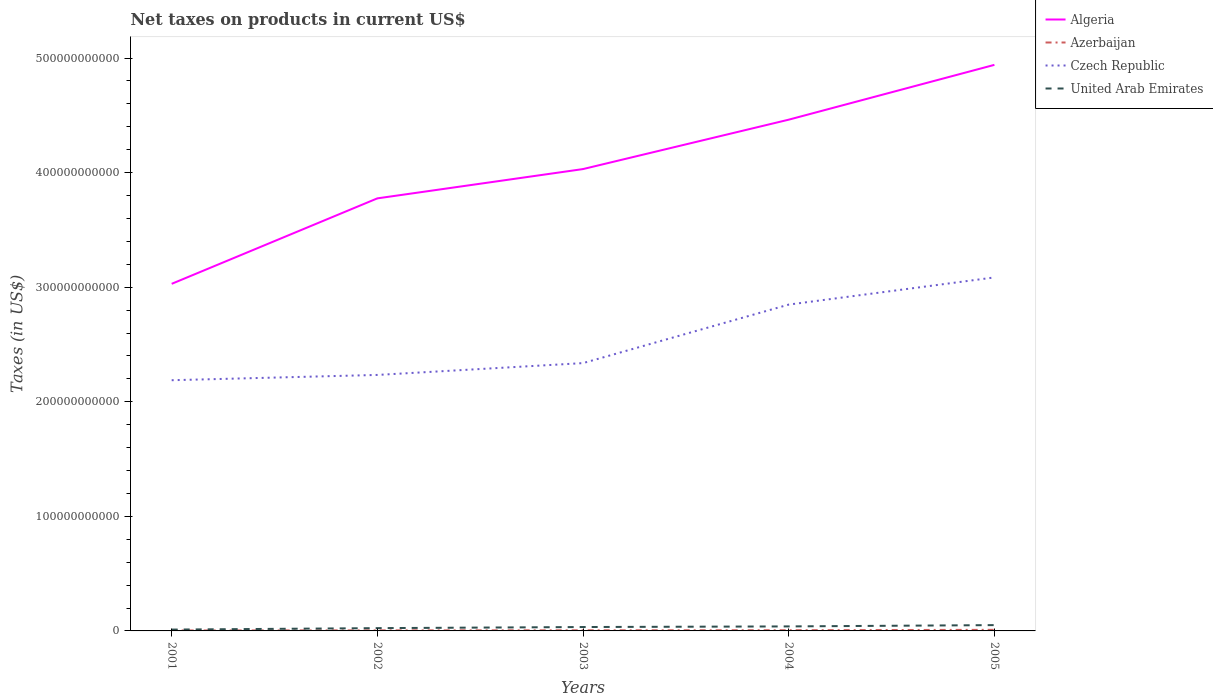Does the line corresponding to Czech Republic intersect with the line corresponding to United Arab Emirates?
Your answer should be very brief. No. Is the number of lines equal to the number of legend labels?
Ensure brevity in your answer.  Yes. Across all years, what is the maximum net taxes on products in Czech Republic?
Keep it short and to the point. 2.19e+11. In which year was the net taxes on products in Czech Republic maximum?
Provide a succinct answer. 2001. What is the total net taxes on products in Czech Republic in the graph?
Keep it short and to the point. -7.48e+1. What is the difference between the highest and the second highest net taxes on products in Algeria?
Keep it short and to the point. 1.91e+11. What is the difference between the highest and the lowest net taxes on products in Czech Republic?
Provide a short and direct response. 2. Is the net taxes on products in Algeria strictly greater than the net taxes on products in Czech Republic over the years?
Your answer should be compact. No. What is the difference between two consecutive major ticks on the Y-axis?
Make the answer very short. 1.00e+11. Does the graph contain grids?
Your answer should be very brief. No. What is the title of the graph?
Offer a very short reply. Net taxes on products in current US$. What is the label or title of the Y-axis?
Provide a succinct answer. Taxes (in US$). What is the Taxes (in US$) in Algeria in 2001?
Keep it short and to the point. 3.03e+11. What is the Taxes (in US$) of Azerbaijan in 2001?
Ensure brevity in your answer.  4.18e+08. What is the Taxes (in US$) of Czech Republic in 2001?
Your answer should be compact. 2.19e+11. What is the Taxes (in US$) in United Arab Emirates in 2001?
Make the answer very short. 1.17e+09. What is the Taxes (in US$) in Algeria in 2002?
Provide a short and direct response. 3.78e+11. What is the Taxes (in US$) of Azerbaijan in 2002?
Give a very brief answer. 4.86e+08. What is the Taxes (in US$) of Czech Republic in 2002?
Your answer should be very brief. 2.23e+11. What is the Taxes (in US$) of United Arab Emirates in 2002?
Provide a succinct answer. 2.43e+09. What is the Taxes (in US$) of Algeria in 2003?
Offer a very short reply. 4.03e+11. What is the Taxes (in US$) of Azerbaijan in 2003?
Your response must be concise. 5.50e+08. What is the Taxes (in US$) in Czech Republic in 2003?
Your answer should be very brief. 2.34e+11. What is the Taxes (in US$) of United Arab Emirates in 2003?
Your answer should be compact. 3.40e+09. What is the Taxes (in US$) of Algeria in 2004?
Your answer should be very brief. 4.46e+11. What is the Taxes (in US$) in Azerbaijan in 2004?
Ensure brevity in your answer.  6.16e+08. What is the Taxes (in US$) in Czech Republic in 2004?
Ensure brevity in your answer.  2.85e+11. What is the Taxes (in US$) in United Arab Emirates in 2004?
Offer a terse response. 3.94e+09. What is the Taxes (in US$) in Algeria in 2005?
Ensure brevity in your answer.  4.94e+11. What is the Taxes (in US$) of Azerbaijan in 2005?
Provide a succinct answer. 9.46e+08. What is the Taxes (in US$) in Czech Republic in 2005?
Offer a very short reply. 3.09e+11. What is the Taxes (in US$) of United Arab Emirates in 2005?
Provide a short and direct response. 5.07e+09. Across all years, what is the maximum Taxes (in US$) in Algeria?
Offer a very short reply. 4.94e+11. Across all years, what is the maximum Taxes (in US$) in Azerbaijan?
Give a very brief answer. 9.46e+08. Across all years, what is the maximum Taxes (in US$) in Czech Republic?
Offer a terse response. 3.09e+11. Across all years, what is the maximum Taxes (in US$) of United Arab Emirates?
Keep it short and to the point. 5.07e+09. Across all years, what is the minimum Taxes (in US$) of Algeria?
Your response must be concise. 3.03e+11. Across all years, what is the minimum Taxes (in US$) in Azerbaijan?
Make the answer very short. 4.18e+08. Across all years, what is the minimum Taxes (in US$) of Czech Republic?
Make the answer very short. 2.19e+11. Across all years, what is the minimum Taxes (in US$) in United Arab Emirates?
Provide a succinct answer. 1.17e+09. What is the total Taxes (in US$) of Algeria in the graph?
Make the answer very short. 2.02e+12. What is the total Taxes (in US$) of Azerbaijan in the graph?
Ensure brevity in your answer.  3.02e+09. What is the total Taxes (in US$) of Czech Republic in the graph?
Offer a terse response. 1.27e+12. What is the total Taxes (in US$) of United Arab Emirates in the graph?
Your response must be concise. 1.60e+1. What is the difference between the Taxes (in US$) in Algeria in 2001 and that in 2002?
Offer a very short reply. -7.46e+1. What is the difference between the Taxes (in US$) in Azerbaijan in 2001 and that in 2002?
Your answer should be very brief. -6.79e+07. What is the difference between the Taxes (in US$) in Czech Republic in 2001 and that in 2002?
Offer a very short reply. -4.61e+09. What is the difference between the Taxes (in US$) of United Arab Emirates in 2001 and that in 2002?
Provide a succinct answer. -1.26e+09. What is the difference between the Taxes (in US$) in Algeria in 2001 and that in 2003?
Keep it short and to the point. -1.00e+11. What is the difference between the Taxes (in US$) in Azerbaijan in 2001 and that in 2003?
Your response must be concise. -1.31e+08. What is the difference between the Taxes (in US$) of Czech Republic in 2001 and that in 2003?
Give a very brief answer. -1.49e+1. What is the difference between the Taxes (in US$) in United Arab Emirates in 2001 and that in 2003?
Your answer should be very brief. -2.23e+09. What is the difference between the Taxes (in US$) of Algeria in 2001 and that in 2004?
Provide a short and direct response. -1.43e+11. What is the difference between the Taxes (in US$) in Azerbaijan in 2001 and that in 2004?
Make the answer very short. -1.97e+08. What is the difference between the Taxes (in US$) of Czech Republic in 2001 and that in 2004?
Offer a terse response. -6.60e+1. What is the difference between the Taxes (in US$) in United Arab Emirates in 2001 and that in 2004?
Give a very brief answer. -2.77e+09. What is the difference between the Taxes (in US$) of Algeria in 2001 and that in 2005?
Make the answer very short. -1.91e+11. What is the difference between the Taxes (in US$) in Azerbaijan in 2001 and that in 2005?
Offer a terse response. -5.28e+08. What is the difference between the Taxes (in US$) in Czech Republic in 2001 and that in 2005?
Offer a terse response. -8.97e+1. What is the difference between the Taxes (in US$) in United Arab Emirates in 2001 and that in 2005?
Ensure brevity in your answer.  -3.90e+09. What is the difference between the Taxes (in US$) in Algeria in 2002 and that in 2003?
Offer a terse response. -2.56e+1. What is the difference between the Taxes (in US$) in Azerbaijan in 2002 and that in 2003?
Your response must be concise. -6.35e+07. What is the difference between the Taxes (in US$) of Czech Republic in 2002 and that in 2003?
Offer a very short reply. -1.03e+1. What is the difference between the Taxes (in US$) of United Arab Emirates in 2002 and that in 2003?
Your response must be concise. -9.66e+08. What is the difference between the Taxes (in US$) in Algeria in 2002 and that in 2004?
Keep it short and to the point. -6.87e+1. What is the difference between the Taxes (in US$) in Azerbaijan in 2002 and that in 2004?
Offer a terse response. -1.29e+08. What is the difference between the Taxes (in US$) of Czech Republic in 2002 and that in 2004?
Provide a short and direct response. -6.14e+1. What is the difference between the Taxes (in US$) in United Arab Emirates in 2002 and that in 2004?
Ensure brevity in your answer.  -1.50e+09. What is the difference between the Taxes (in US$) of Algeria in 2002 and that in 2005?
Your answer should be compact. -1.17e+11. What is the difference between the Taxes (in US$) in Azerbaijan in 2002 and that in 2005?
Offer a very short reply. -4.60e+08. What is the difference between the Taxes (in US$) of Czech Republic in 2002 and that in 2005?
Provide a succinct answer. -8.51e+1. What is the difference between the Taxes (in US$) in United Arab Emirates in 2002 and that in 2005?
Ensure brevity in your answer.  -2.64e+09. What is the difference between the Taxes (in US$) of Algeria in 2003 and that in 2004?
Provide a succinct answer. -4.31e+1. What is the difference between the Taxes (in US$) in Azerbaijan in 2003 and that in 2004?
Ensure brevity in your answer.  -6.60e+07. What is the difference between the Taxes (in US$) in Czech Republic in 2003 and that in 2004?
Keep it short and to the point. -5.11e+1. What is the difference between the Taxes (in US$) in United Arab Emirates in 2003 and that in 2004?
Your response must be concise. -5.39e+08. What is the difference between the Taxes (in US$) in Algeria in 2003 and that in 2005?
Your answer should be very brief. -9.09e+1. What is the difference between the Taxes (in US$) of Azerbaijan in 2003 and that in 2005?
Your answer should be compact. -3.97e+08. What is the difference between the Taxes (in US$) of Czech Republic in 2003 and that in 2005?
Keep it short and to the point. -7.48e+1. What is the difference between the Taxes (in US$) of United Arab Emirates in 2003 and that in 2005?
Ensure brevity in your answer.  -1.67e+09. What is the difference between the Taxes (in US$) in Algeria in 2004 and that in 2005?
Offer a terse response. -4.78e+1. What is the difference between the Taxes (in US$) in Azerbaijan in 2004 and that in 2005?
Your answer should be very brief. -3.31e+08. What is the difference between the Taxes (in US$) in Czech Republic in 2004 and that in 2005?
Provide a succinct answer. -2.37e+1. What is the difference between the Taxes (in US$) of United Arab Emirates in 2004 and that in 2005?
Your answer should be compact. -1.14e+09. What is the difference between the Taxes (in US$) in Algeria in 2001 and the Taxes (in US$) in Azerbaijan in 2002?
Ensure brevity in your answer.  3.02e+11. What is the difference between the Taxes (in US$) in Algeria in 2001 and the Taxes (in US$) in Czech Republic in 2002?
Keep it short and to the point. 7.95e+1. What is the difference between the Taxes (in US$) in Algeria in 2001 and the Taxes (in US$) in United Arab Emirates in 2002?
Offer a very short reply. 3.00e+11. What is the difference between the Taxes (in US$) of Azerbaijan in 2001 and the Taxes (in US$) of Czech Republic in 2002?
Provide a short and direct response. -2.23e+11. What is the difference between the Taxes (in US$) in Azerbaijan in 2001 and the Taxes (in US$) in United Arab Emirates in 2002?
Your answer should be very brief. -2.01e+09. What is the difference between the Taxes (in US$) in Czech Republic in 2001 and the Taxes (in US$) in United Arab Emirates in 2002?
Your answer should be very brief. 2.16e+11. What is the difference between the Taxes (in US$) of Algeria in 2001 and the Taxes (in US$) of Azerbaijan in 2003?
Offer a terse response. 3.02e+11. What is the difference between the Taxes (in US$) in Algeria in 2001 and the Taxes (in US$) in Czech Republic in 2003?
Your answer should be compact. 6.92e+1. What is the difference between the Taxes (in US$) in Algeria in 2001 and the Taxes (in US$) in United Arab Emirates in 2003?
Your answer should be very brief. 3.00e+11. What is the difference between the Taxes (in US$) in Azerbaijan in 2001 and the Taxes (in US$) in Czech Republic in 2003?
Keep it short and to the point. -2.33e+11. What is the difference between the Taxes (in US$) in Azerbaijan in 2001 and the Taxes (in US$) in United Arab Emirates in 2003?
Keep it short and to the point. -2.98e+09. What is the difference between the Taxes (in US$) in Czech Republic in 2001 and the Taxes (in US$) in United Arab Emirates in 2003?
Ensure brevity in your answer.  2.15e+11. What is the difference between the Taxes (in US$) of Algeria in 2001 and the Taxes (in US$) of Azerbaijan in 2004?
Offer a very short reply. 3.02e+11. What is the difference between the Taxes (in US$) in Algeria in 2001 and the Taxes (in US$) in Czech Republic in 2004?
Ensure brevity in your answer.  1.81e+1. What is the difference between the Taxes (in US$) in Algeria in 2001 and the Taxes (in US$) in United Arab Emirates in 2004?
Your answer should be very brief. 2.99e+11. What is the difference between the Taxes (in US$) of Azerbaijan in 2001 and the Taxes (in US$) of Czech Republic in 2004?
Provide a succinct answer. -2.84e+11. What is the difference between the Taxes (in US$) of Azerbaijan in 2001 and the Taxes (in US$) of United Arab Emirates in 2004?
Your answer should be very brief. -3.52e+09. What is the difference between the Taxes (in US$) of Czech Republic in 2001 and the Taxes (in US$) of United Arab Emirates in 2004?
Make the answer very short. 2.15e+11. What is the difference between the Taxes (in US$) in Algeria in 2001 and the Taxes (in US$) in Azerbaijan in 2005?
Provide a short and direct response. 3.02e+11. What is the difference between the Taxes (in US$) in Algeria in 2001 and the Taxes (in US$) in Czech Republic in 2005?
Offer a very short reply. -5.60e+09. What is the difference between the Taxes (in US$) in Algeria in 2001 and the Taxes (in US$) in United Arab Emirates in 2005?
Make the answer very short. 2.98e+11. What is the difference between the Taxes (in US$) in Azerbaijan in 2001 and the Taxes (in US$) in Czech Republic in 2005?
Your answer should be compact. -3.08e+11. What is the difference between the Taxes (in US$) in Azerbaijan in 2001 and the Taxes (in US$) in United Arab Emirates in 2005?
Your answer should be compact. -4.65e+09. What is the difference between the Taxes (in US$) of Czech Republic in 2001 and the Taxes (in US$) of United Arab Emirates in 2005?
Provide a succinct answer. 2.14e+11. What is the difference between the Taxes (in US$) of Algeria in 2002 and the Taxes (in US$) of Azerbaijan in 2003?
Offer a terse response. 3.77e+11. What is the difference between the Taxes (in US$) of Algeria in 2002 and the Taxes (in US$) of Czech Republic in 2003?
Your answer should be very brief. 1.44e+11. What is the difference between the Taxes (in US$) in Algeria in 2002 and the Taxes (in US$) in United Arab Emirates in 2003?
Your answer should be very brief. 3.74e+11. What is the difference between the Taxes (in US$) in Azerbaijan in 2002 and the Taxes (in US$) in Czech Republic in 2003?
Offer a very short reply. -2.33e+11. What is the difference between the Taxes (in US$) in Azerbaijan in 2002 and the Taxes (in US$) in United Arab Emirates in 2003?
Offer a very short reply. -2.91e+09. What is the difference between the Taxes (in US$) in Czech Republic in 2002 and the Taxes (in US$) in United Arab Emirates in 2003?
Make the answer very short. 2.20e+11. What is the difference between the Taxes (in US$) of Algeria in 2002 and the Taxes (in US$) of Azerbaijan in 2004?
Offer a very short reply. 3.77e+11. What is the difference between the Taxes (in US$) of Algeria in 2002 and the Taxes (in US$) of Czech Republic in 2004?
Your answer should be very brief. 9.27e+1. What is the difference between the Taxes (in US$) of Algeria in 2002 and the Taxes (in US$) of United Arab Emirates in 2004?
Your answer should be very brief. 3.74e+11. What is the difference between the Taxes (in US$) of Azerbaijan in 2002 and the Taxes (in US$) of Czech Republic in 2004?
Offer a very short reply. -2.84e+11. What is the difference between the Taxes (in US$) of Azerbaijan in 2002 and the Taxes (in US$) of United Arab Emirates in 2004?
Keep it short and to the point. -3.45e+09. What is the difference between the Taxes (in US$) of Czech Republic in 2002 and the Taxes (in US$) of United Arab Emirates in 2004?
Your answer should be very brief. 2.19e+11. What is the difference between the Taxes (in US$) in Algeria in 2002 and the Taxes (in US$) in Azerbaijan in 2005?
Your answer should be compact. 3.77e+11. What is the difference between the Taxes (in US$) of Algeria in 2002 and the Taxes (in US$) of Czech Republic in 2005?
Your answer should be very brief. 6.90e+1. What is the difference between the Taxes (in US$) of Algeria in 2002 and the Taxes (in US$) of United Arab Emirates in 2005?
Provide a succinct answer. 3.72e+11. What is the difference between the Taxes (in US$) in Azerbaijan in 2002 and the Taxes (in US$) in Czech Republic in 2005?
Offer a very short reply. -3.08e+11. What is the difference between the Taxes (in US$) in Azerbaijan in 2002 and the Taxes (in US$) in United Arab Emirates in 2005?
Provide a short and direct response. -4.58e+09. What is the difference between the Taxes (in US$) of Czech Republic in 2002 and the Taxes (in US$) of United Arab Emirates in 2005?
Your response must be concise. 2.18e+11. What is the difference between the Taxes (in US$) in Algeria in 2003 and the Taxes (in US$) in Azerbaijan in 2004?
Give a very brief answer. 4.02e+11. What is the difference between the Taxes (in US$) of Algeria in 2003 and the Taxes (in US$) of Czech Republic in 2004?
Provide a succinct answer. 1.18e+11. What is the difference between the Taxes (in US$) in Algeria in 2003 and the Taxes (in US$) in United Arab Emirates in 2004?
Make the answer very short. 3.99e+11. What is the difference between the Taxes (in US$) of Azerbaijan in 2003 and the Taxes (in US$) of Czech Republic in 2004?
Give a very brief answer. -2.84e+11. What is the difference between the Taxes (in US$) in Azerbaijan in 2003 and the Taxes (in US$) in United Arab Emirates in 2004?
Make the answer very short. -3.39e+09. What is the difference between the Taxes (in US$) of Czech Republic in 2003 and the Taxes (in US$) of United Arab Emirates in 2004?
Ensure brevity in your answer.  2.30e+11. What is the difference between the Taxes (in US$) of Algeria in 2003 and the Taxes (in US$) of Azerbaijan in 2005?
Provide a short and direct response. 4.02e+11. What is the difference between the Taxes (in US$) of Algeria in 2003 and the Taxes (in US$) of Czech Republic in 2005?
Your answer should be compact. 9.46e+1. What is the difference between the Taxes (in US$) of Algeria in 2003 and the Taxes (in US$) of United Arab Emirates in 2005?
Provide a succinct answer. 3.98e+11. What is the difference between the Taxes (in US$) in Azerbaijan in 2003 and the Taxes (in US$) in Czech Republic in 2005?
Your answer should be very brief. -3.08e+11. What is the difference between the Taxes (in US$) in Azerbaijan in 2003 and the Taxes (in US$) in United Arab Emirates in 2005?
Provide a succinct answer. -4.52e+09. What is the difference between the Taxes (in US$) in Czech Republic in 2003 and the Taxes (in US$) in United Arab Emirates in 2005?
Make the answer very short. 2.29e+11. What is the difference between the Taxes (in US$) of Algeria in 2004 and the Taxes (in US$) of Azerbaijan in 2005?
Keep it short and to the point. 4.45e+11. What is the difference between the Taxes (in US$) in Algeria in 2004 and the Taxes (in US$) in Czech Republic in 2005?
Offer a terse response. 1.38e+11. What is the difference between the Taxes (in US$) in Algeria in 2004 and the Taxes (in US$) in United Arab Emirates in 2005?
Give a very brief answer. 4.41e+11. What is the difference between the Taxes (in US$) of Azerbaijan in 2004 and the Taxes (in US$) of Czech Republic in 2005?
Give a very brief answer. -3.08e+11. What is the difference between the Taxes (in US$) of Azerbaijan in 2004 and the Taxes (in US$) of United Arab Emirates in 2005?
Keep it short and to the point. -4.45e+09. What is the difference between the Taxes (in US$) in Czech Republic in 2004 and the Taxes (in US$) in United Arab Emirates in 2005?
Your answer should be very brief. 2.80e+11. What is the average Taxes (in US$) of Algeria per year?
Your response must be concise. 4.05e+11. What is the average Taxes (in US$) of Azerbaijan per year?
Provide a short and direct response. 6.03e+08. What is the average Taxes (in US$) of Czech Republic per year?
Your answer should be compact. 2.54e+11. What is the average Taxes (in US$) in United Arab Emirates per year?
Offer a very short reply. 3.20e+09. In the year 2001, what is the difference between the Taxes (in US$) in Algeria and Taxes (in US$) in Azerbaijan?
Your response must be concise. 3.02e+11. In the year 2001, what is the difference between the Taxes (in US$) in Algeria and Taxes (in US$) in Czech Republic?
Offer a terse response. 8.41e+1. In the year 2001, what is the difference between the Taxes (in US$) of Algeria and Taxes (in US$) of United Arab Emirates?
Your response must be concise. 3.02e+11. In the year 2001, what is the difference between the Taxes (in US$) of Azerbaijan and Taxes (in US$) of Czech Republic?
Your response must be concise. -2.18e+11. In the year 2001, what is the difference between the Taxes (in US$) in Azerbaijan and Taxes (in US$) in United Arab Emirates?
Give a very brief answer. -7.49e+08. In the year 2001, what is the difference between the Taxes (in US$) in Czech Republic and Taxes (in US$) in United Arab Emirates?
Your response must be concise. 2.18e+11. In the year 2002, what is the difference between the Taxes (in US$) of Algeria and Taxes (in US$) of Azerbaijan?
Offer a very short reply. 3.77e+11. In the year 2002, what is the difference between the Taxes (in US$) in Algeria and Taxes (in US$) in Czech Republic?
Provide a succinct answer. 1.54e+11. In the year 2002, what is the difference between the Taxes (in US$) in Algeria and Taxes (in US$) in United Arab Emirates?
Your response must be concise. 3.75e+11. In the year 2002, what is the difference between the Taxes (in US$) in Azerbaijan and Taxes (in US$) in Czech Republic?
Provide a short and direct response. -2.23e+11. In the year 2002, what is the difference between the Taxes (in US$) in Azerbaijan and Taxes (in US$) in United Arab Emirates?
Make the answer very short. -1.94e+09. In the year 2002, what is the difference between the Taxes (in US$) in Czech Republic and Taxes (in US$) in United Arab Emirates?
Your answer should be compact. 2.21e+11. In the year 2003, what is the difference between the Taxes (in US$) of Algeria and Taxes (in US$) of Azerbaijan?
Make the answer very short. 4.03e+11. In the year 2003, what is the difference between the Taxes (in US$) in Algeria and Taxes (in US$) in Czech Republic?
Ensure brevity in your answer.  1.69e+11. In the year 2003, what is the difference between the Taxes (in US$) in Algeria and Taxes (in US$) in United Arab Emirates?
Make the answer very short. 4.00e+11. In the year 2003, what is the difference between the Taxes (in US$) in Azerbaijan and Taxes (in US$) in Czech Republic?
Give a very brief answer. -2.33e+11. In the year 2003, what is the difference between the Taxes (in US$) in Azerbaijan and Taxes (in US$) in United Arab Emirates?
Your response must be concise. -2.85e+09. In the year 2003, what is the difference between the Taxes (in US$) of Czech Republic and Taxes (in US$) of United Arab Emirates?
Keep it short and to the point. 2.30e+11. In the year 2004, what is the difference between the Taxes (in US$) of Algeria and Taxes (in US$) of Azerbaijan?
Ensure brevity in your answer.  4.46e+11. In the year 2004, what is the difference between the Taxes (in US$) in Algeria and Taxes (in US$) in Czech Republic?
Give a very brief answer. 1.61e+11. In the year 2004, what is the difference between the Taxes (in US$) in Algeria and Taxes (in US$) in United Arab Emirates?
Keep it short and to the point. 4.42e+11. In the year 2004, what is the difference between the Taxes (in US$) in Azerbaijan and Taxes (in US$) in Czech Republic?
Your response must be concise. -2.84e+11. In the year 2004, what is the difference between the Taxes (in US$) of Azerbaijan and Taxes (in US$) of United Arab Emirates?
Your answer should be very brief. -3.32e+09. In the year 2004, what is the difference between the Taxes (in US$) of Czech Republic and Taxes (in US$) of United Arab Emirates?
Give a very brief answer. 2.81e+11. In the year 2005, what is the difference between the Taxes (in US$) in Algeria and Taxes (in US$) in Azerbaijan?
Make the answer very short. 4.93e+11. In the year 2005, what is the difference between the Taxes (in US$) in Algeria and Taxes (in US$) in Czech Republic?
Give a very brief answer. 1.86e+11. In the year 2005, what is the difference between the Taxes (in US$) of Algeria and Taxes (in US$) of United Arab Emirates?
Your answer should be compact. 4.89e+11. In the year 2005, what is the difference between the Taxes (in US$) of Azerbaijan and Taxes (in US$) of Czech Republic?
Your response must be concise. -3.08e+11. In the year 2005, what is the difference between the Taxes (in US$) of Azerbaijan and Taxes (in US$) of United Arab Emirates?
Ensure brevity in your answer.  -4.12e+09. In the year 2005, what is the difference between the Taxes (in US$) in Czech Republic and Taxes (in US$) in United Arab Emirates?
Offer a terse response. 3.03e+11. What is the ratio of the Taxes (in US$) of Algeria in 2001 to that in 2002?
Your answer should be compact. 0.8. What is the ratio of the Taxes (in US$) in Azerbaijan in 2001 to that in 2002?
Offer a terse response. 0.86. What is the ratio of the Taxes (in US$) of Czech Republic in 2001 to that in 2002?
Keep it short and to the point. 0.98. What is the ratio of the Taxes (in US$) of United Arab Emirates in 2001 to that in 2002?
Provide a short and direct response. 0.48. What is the ratio of the Taxes (in US$) of Algeria in 2001 to that in 2003?
Provide a short and direct response. 0.75. What is the ratio of the Taxes (in US$) in Azerbaijan in 2001 to that in 2003?
Provide a succinct answer. 0.76. What is the ratio of the Taxes (in US$) of Czech Republic in 2001 to that in 2003?
Your response must be concise. 0.94. What is the ratio of the Taxes (in US$) of United Arab Emirates in 2001 to that in 2003?
Offer a very short reply. 0.34. What is the ratio of the Taxes (in US$) of Algeria in 2001 to that in 2004?
Offer a terse response. 0.68. What is the ratio of the Taxes (in US$) in Azerbaijan in 2001 to that in 2004?
Give a very brief answer. 0.68. What is the ratio of the Taxes (in US$) of Czech Republic in 2001 to that in 2004?
Your response must be concise. 0.77. What is the ratio of the Taxes (in US$) of United Arab Emirates in 2001 to that in 2004?
Your answer should be very brief. 0.3. What is the ratio of the Taxes (in US$) of Algeria in 2001 to that in 2005?
Your response must be concise. 0.61. What is the ratio of the Taxes (in US$) of Azerbaijan in 2001 to that in 2005?
Ensure brevity in your answer.  0.44. What is the ratio of the Taxes (in US$) in Czech Republic in 2001 to that in 2005?
Your answer should be very brief. 0.71. What is the ratio of the Taxes (in US$) in United Arab Emirates in 2001 to that in 2005?
Your answer should be very brief. 0.23. What is the ratio of the Taxes (in US$) of Algeria in 2002 to that in 2003?
Offer a terse response. 0.94. What is the ratio of the Taxes (in US$) of Azerbaijan in 2002 to that in 2003?
Your answer should be compact. 0.88. What is the ratio of the Taxes (in US$) of Czech Republic in 2002 to that in 2003?
Keep it short and to the point. 0.96. What is the ratio of the Taxes (in US$) of United Arab Emirates in 2002 to that in 2003?
Offer a very short reply. 0.72. What is the ratio of the Taxes (in US$) of Algeria in 2002 to that in 2004?
Provide a succinct answer. 0.85. What is the ratio of the Taxes (in US$) of Azerbaijan in 2002 to that in 2004?
Ensure brevity in your answer.  0.79. What is the ratio of the Taxes (in US$) in Czech Republic in 2002 to that in 2004?
Ensure brevity in your answer.  0.78. What is the ratio of the Taxes (in US$) in United Arab Emirates in 2002 to that in 2004?
Ensure brevity in your answer.  0.62. What is the ratio of the Taxes (in US$) in Algeria in 2002 to that in 2005?
Your answer should be very brief. 0.76. What is the ratio of the Taxes (in US$) in Azerbaijan in 2002 to that in 2005?
Make the answer very short. 0.51. What is the ratio of the Taxes (in US$) in Czech Republic in 2002 to that in 2005?
Ensure brevity in your answer.  0.72. What is the ratio of the Taxes (in US$) of United Arab Emirates in 2002 to that in 2005?
Your answer should be very brief. 0.48. What is the ratio of the Taxes (in US$) of Algeria in 2003 to that in 2004?
Offer a terse response. 0.9. What is the ratio of the Taxes (in US$) of Azerbaijan in 2003 to that in 2004?
Provide a short and direct response. 0.89. What is the ratio of the Taxes (in US$) in Czech Republic in 2003 to that in 2004?
Offer a terse response. 0.82. What is the ratio of the Taxes (in US$) in United Arab Emirates in 2003 to that in 2004?
Provide a succinct answer. 0.86. What is the ratio of the Taxes (in US$) of Algeria in 2003 to that in 2005?
Provide a short and direct response. 0.82. What is the ratio of the Taxes (in US$) in Azerbaijan in 2003 to that in 2005?
Give a very brief answer. 0.58. What is the ratio of the Taxes (in US$) in Czech Republic in 2003 to that in 2005?
Your answer should be very brief. 0.76. What is the ratio of the Taxes (in US$) in United Arab Emirates in 2003 to that in 2005?
Your answer should be compact. 0.67. What is the ratio of the Taxes (in US$) of Algeria in 2004 to that in 2005?
Your answer should be compact. 0.9. What is the ratio of the Taxes (in US$) of Azerbaijan in 2004 to that in 2005?
Keep it short and to the point. 0.65. What is the ratio of the Taxes (in US$) in Czech Republic in 2004 to that in 2005?
Your answer should be compact. 0.92. What is the ratio of the Taxes (in US$) of United Arab Emirates in 2004 to that in 2005?
Give a very brief answer. 0.78. What is the difference between the highest and the second highest Taxes (in US$) of Algeria?
Make the answer very short. 4.78e+1. What is the difference between the highest and the second highest Taxes (in US$) in Azerbaijan?
Your response must be concise. 3.31e+08. What is the difference between the highest and the second highest Taxes (in US$) of Czech Republic?
Provide a succinct answer. 2.37e+1. What is the difference between the highest and the second highest Taxes (in US$) in United Arab Emirates?
Make the answer very short. 1.14e+09. What is the difference between the highest and the lowest Taxes (in US$) of Algeria?
Give a very brief answer. 1.91e+11. What is the difference between the highest and the lowest Taxes (in US$) in Azerbaijan?
Offer a terse response. 5.28e+08. What is the difference between the highest and the lowest Taxes (in US$) of Czech Republic?
Provide a short and direct response. 8.97e+1. What is the difference between the highest and the lowest Taxes (in US$) of United Arab Emirates?
Your response must be concise. 3.90e+09. 